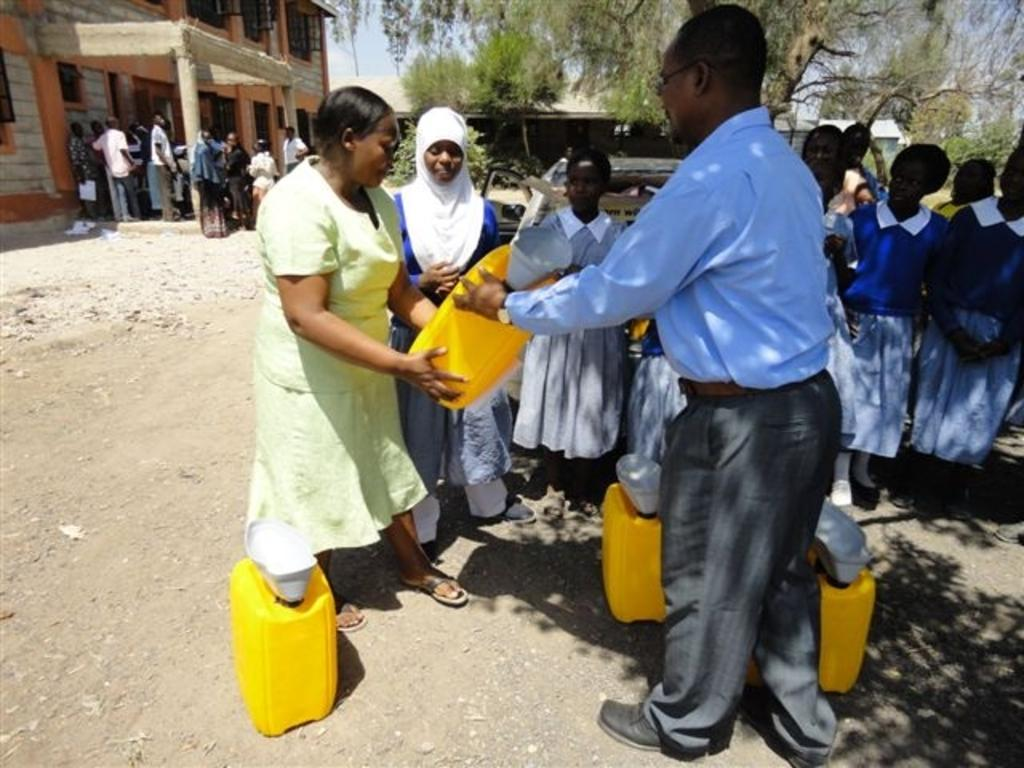How many people are in the image? There are people in the image, but the exact number is not specified. What color are the cans in the image? The cans in the image are yellow. What type of vegetation is present in the image? There are trees in the image. What type of structure can be seen in the image? There is a building and a shed in the image. What is visible in the sky in the image? The sky is visible in the image. What are two people doing with a yellow can in the image? Two people are holding a yellow can in the image. Where is the wrench located in the image? There is no wrench present in the image. Is there a sink visible in the image? No, there is no sink visible in the image. 